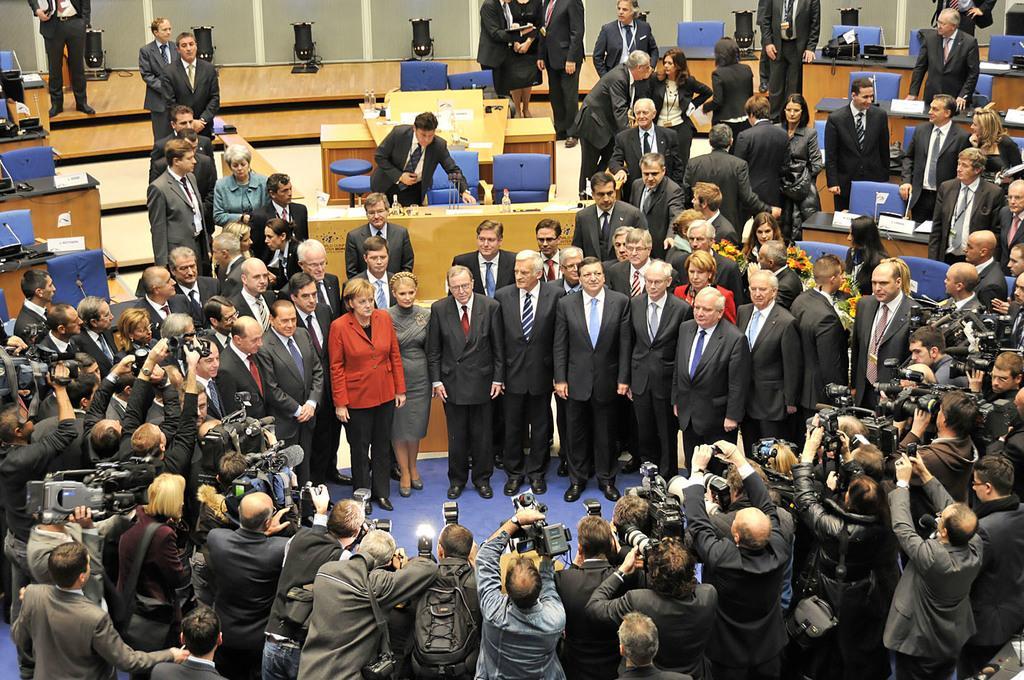Please provide a concise description of this image. In this image we can able to see some persons standing in the middle posing to the cameras, and there are some people taking pictures, we can able to see some tables and chairs, there are mics on the tables, lights on on the ground, and few persons are carrying bouquets 